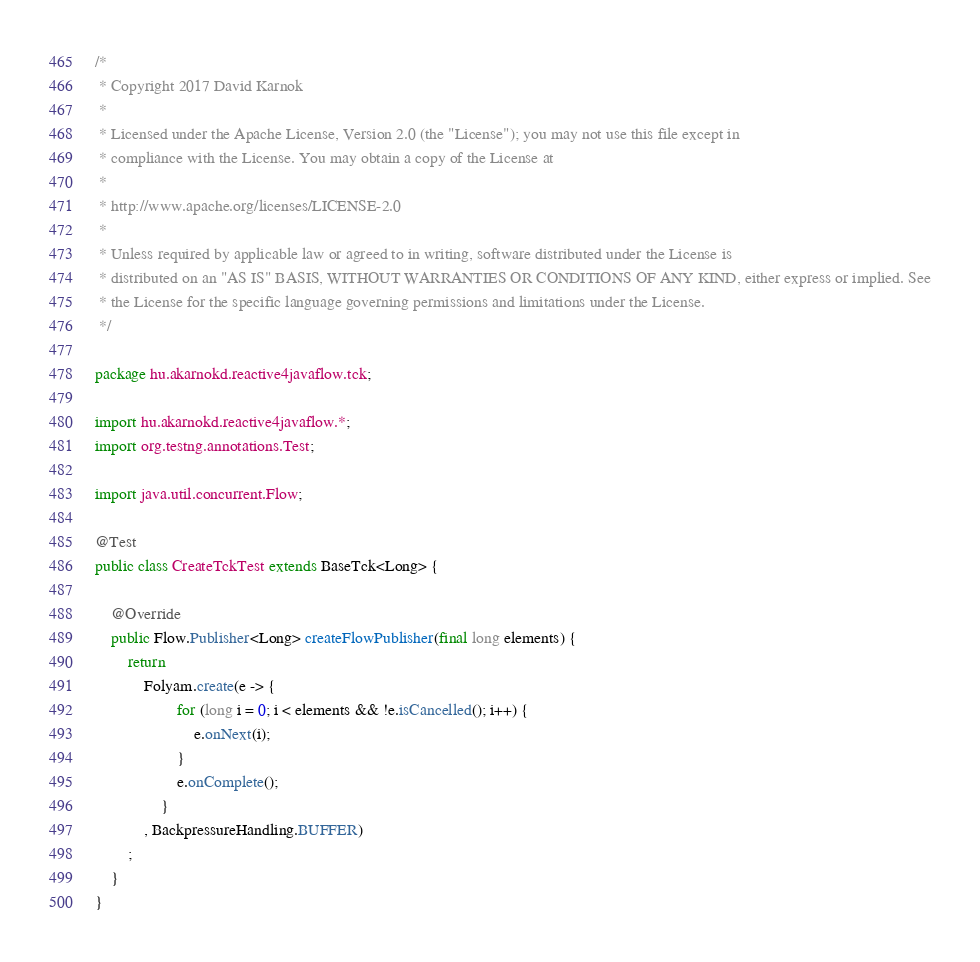Convert code to text. <code><loc_0><loc_0><loc_500><loc_500><_Java_>/*
 * Copyright 2017 David Karnok
 *
 * Licensed under the Apache License, Version 2.0 (the "License"); you may not use this file except in
 * compliance with the License. You may obtain a copy of the License at
 *
 * http://www.apache.org/licenses/LICENSE-2.0
 *
 * Unless required by applicable law or agreed to in writing, software distributed under the License is
 * distributed on an "AS IS" BASIS, WITHOUT WARRANTIES OR CONDITIONS OF ANY KIND, either express or implied. See
 * the License for the specific language governing permissions and limitations under the License.
 */

package hu.akarnokd.reactive4javaflow.tck;

import hu.akarnokd.reactive4javaflow.*;
import org.testng.annotations.Test;

import java.util.concurrent.Flow;

@Test
public class CreateTckTest extends BaseTck<Long> {

    @Override
    public Flow.Publisher<Long> createFlowPublisher(final long elements) {
        return
            Folyam.create(e -> {
                    for (long i = 0; i < elements && !e.isCancelled(); i++) {
                        e.onNext(i);
                    }
                    e.onComplete();
                }
            , BackpressureHandling.BUFFER)
        ;
    }
}
</code> 